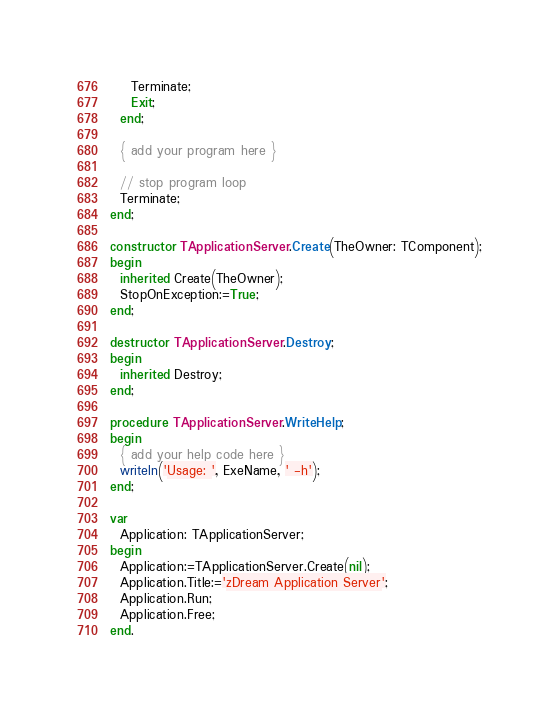Convert code to text. <code><loc_0><loc_0><loc_500><loc_500><_Pascal_>    Terminate;
    Exit;
  end;

  { add your program here }

  // stop program loop
  Terminate;
end;

constructor TApplicationServer.Create(TheOwner: TComponent);
begin
  inherited Create(TheOwner);
  StopOnException:=True;
end;

destructor TApplicationServer.Destroy;
begin
  inherited Destroy;
end;

procedure TApplicationServer.WriteHelp;
begin
  { add your help code here }
  writeln('Usage: ', ExeName, ' -h');
end;

var
  Application: TApplicationServer;
begin
  Application:=TApplicationServer.Create(nil);
  Application.Title:='zDream Application Server';
  Application.Run;
  Application.Free;
end.

</code> 